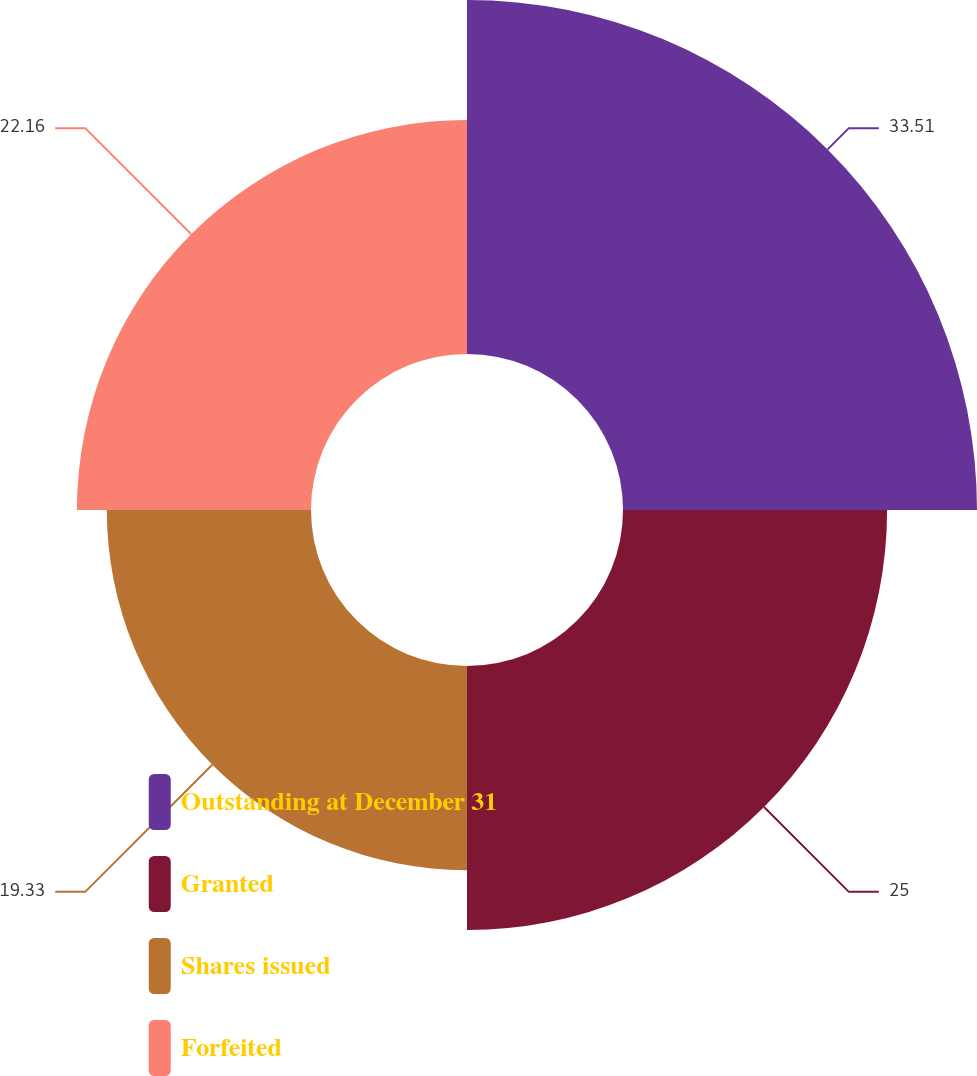Convert chart. <chart><loc_0><loc_0><loc_500><loc_500><pie_chart><fcel>Outstanding at December 31<fcel>Granted<fcel>Shares issued<fcel>Forfeited<nl><fcel>33.51%<fcel>25.0%<fcel>19.33%<fcel>22.16%<nl></chart> 